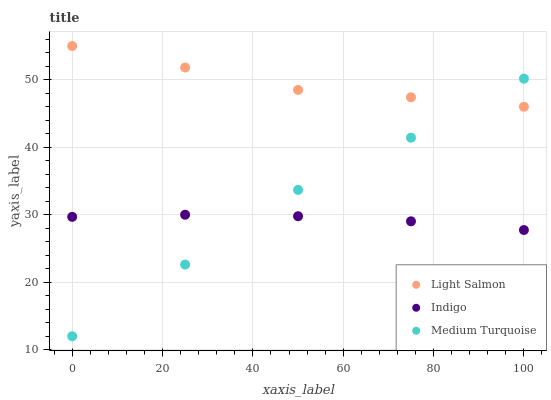Does Indigo have the minimum area under the curve?
Answer yes or no. Yes. Does Light Salmon have the maximum area under the curve?
Answer yes or no. Yes. Does Medium Turquoise have the minimum area under the curve?
Answer yes or no. No. Does Medium Turquoise have the maximum area under the curve?
Answer yes or no. No. Is Indigo the smoothest?
Answer yes or no. Yes. Is Medium Turquoise the roughest?
Answer yes or no. Yes. Is Medium Turquoise the smoothest?
Answer yes or no. No. Is Indigo the roughest?
Answer yes or no. No. Does Medium Turquoise have the lowest value?
Answer yes or no. Yes. Does Indigo have the lowest value?
Answer yes or no. No. Does Light Salmon have the highest value?
Answer yes or no. Yes. Does Medium Turquoise have the highest value?
Answer yes or no. No. Is Indigo less than Light Salmon?
Answer yes or no. Yes. Is Light Salmon greater than Indigo?
Answer yes or no. Yes. Does Medium Turquoise intersect Light Salmon?
Answer yes or no. Yes. Is Medium Turquoise less than Light Salmon?
Answer yes or no. No. Is Medium Turquoise greater than Light Salmon?
Answer yes or no. No. Does Indigo intersect Light Salmon?
Answer yes or no. No. 